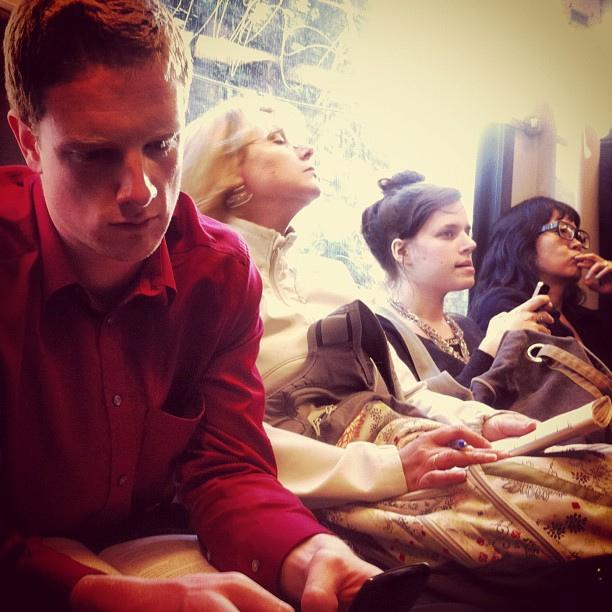The expression on the people's faces reveal that the bus is what? delayed 